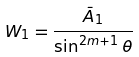Convert formula to latex. <formula><loc_0><loc_0><loc_500><loc_500>W _ { 1 } = \frac { \bar { A } _ { 1 } } { \sin ^ { 2 m + 1 } \theta }</formula> 